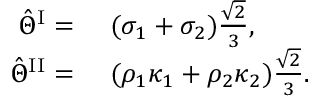Convert formula to latex. <formula><loc_0><loc_0><loc_500><loc_500>\begin{array} { r l } { \hat { \Theta } ^ { I } = } & ( \sigma _ { 1 } + \sigma _ { 2 } ) \frac { \sqrt { 2 } } { 3 } , } \\ { \hat { \Theta } ^ { I I } = } & ( \rho _ { 1 } \kappa _ { 1 } + \rho _ { 2 } \kappa _ { 2 } ) \frac { \sqrt { 2 } } { 3 } . } \end{array}</formula> 